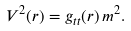<formula> <loc_0><loc_0><loc_500><loc_500>V ^ { 2 } ( r ) = g _ { t t } ( r ) \, m ^ { 2 } .</formula> 